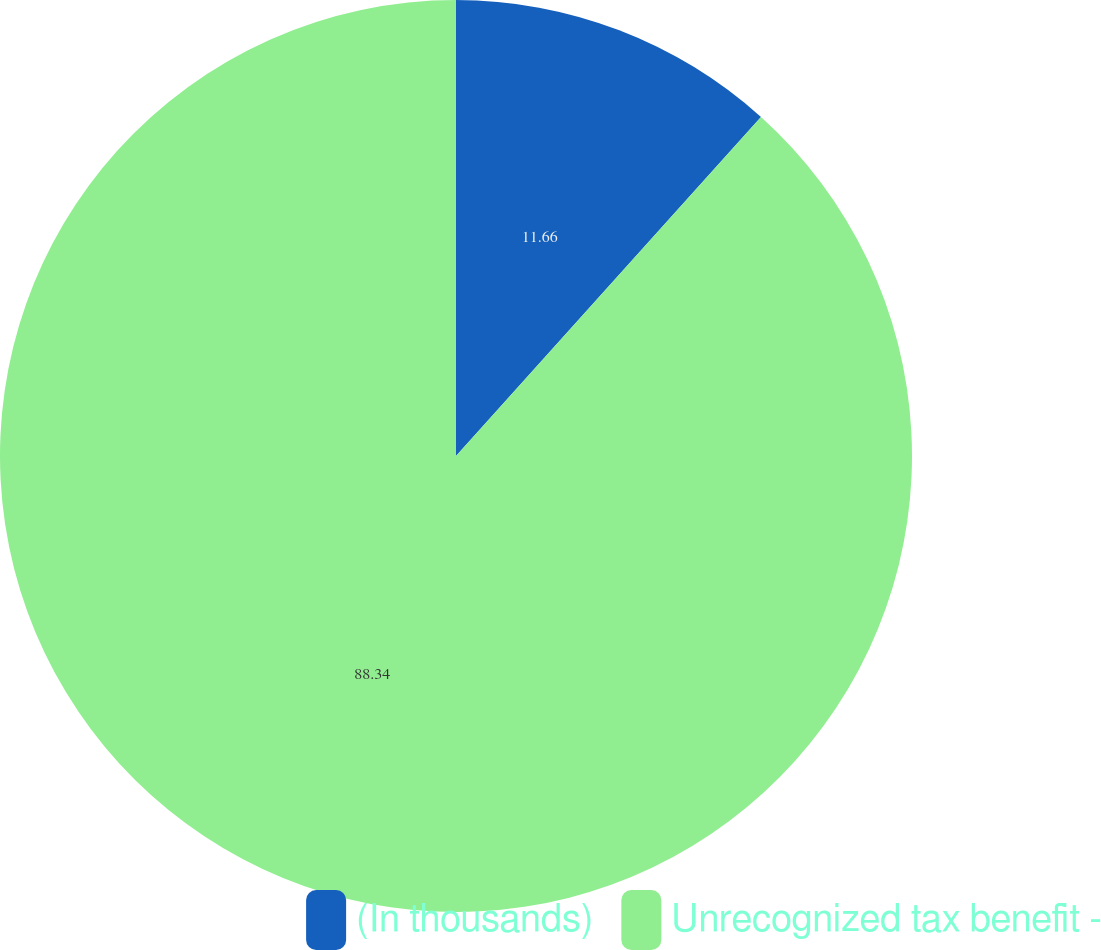<chart> <loc_0><loc_0><loc_500><loc_500><pie_chart><fcel>(In thousands)<fcel>Unrecognized tax benefit -<nl><fcel>11.66%<fcel>88.34%<nl></chart> 